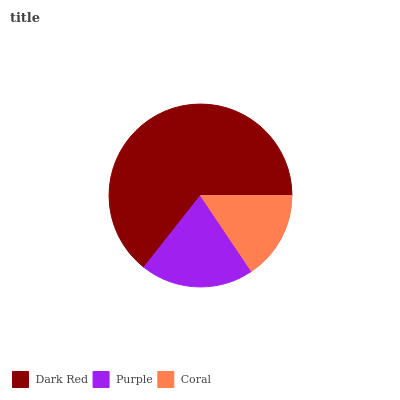Is Coral the minimum?
Answer yes or no. Yes. Is Dark Red the maximum?
Answer yes or no. Yes. Is Purple the minimum?
Answer yes or no. No. Is Purple the maximum?
Answer yes or no. No. Is Dark Red greater than Purple?
Answer yes or no. Yes. Is Purple less than Dark Red?
Answer yes or no. Yes. Is Purple greater than Dark Red?
Answer yes or no. No. Is Dark Red less than Purple?
Answer yes or no. No. Is Purple the high median?
Answer yes or no. Yes. Is Purple the low median?
Answer yes or no. Yes. Is Coral the high median?
Answer yes or no. No. Is Dark Red the low median?
Answer yes or no. No. 